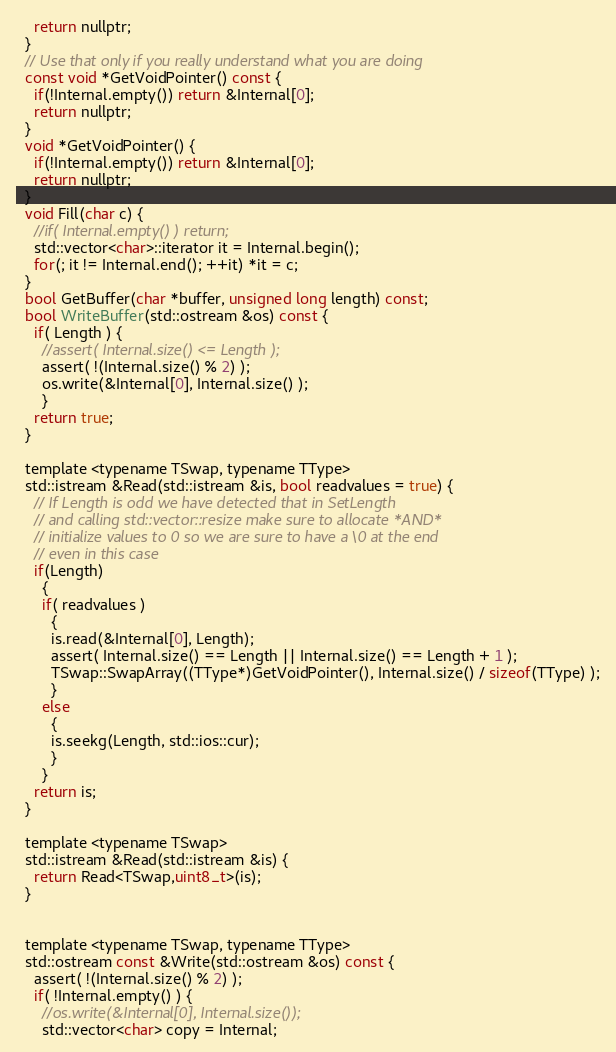<code> <loc_0><loc_0><loc_500><loc_500><_C_>    return nullptr;
  }
  // Use that only if you really understand what you are doing
  const void *GetVoidPointer() const {
    if(!Internal.empty()) return &Internal[0];
    return nullptr;
  }
  void *GetVoidPointer() {
    if(!Internal.empty()) return &Internal[0];
    return nullptr;
  }
  void Fill(char c) {
    //if( Internal.empty() ) return;
    std::vector<char>::iterator it = Internal.begin();
    for(; it != Internal.end(); ++it) *it = c;
  }
  bool GetBuffer(char *buffer, unsigned long length) const;
  bool WriteBuffer(std::ostream &os) const {
    if( Length ) {
      //assert( Internal.size() <= Length );
      assert( !(Internal.size() % 2) );
      os.write(&Internal[0], Internal.size() );
      }
    return true;
  }

  template <typename TSwap, typename TType>
  std::istream &Read(std::istream &is, bool readvalues = true) {
    // If Length is odd we have detected that in SetLength
    // and calling std::vector::resize make sure to allocate *AND*
    // initialize values to 0 so we are sure to have a \0 at the end
    // even in this case
    if(Length)
      {
      if( readvalues )
        {
        is.read(&Internal[0], Length);
        assert( Internal.size() == Length || Internal.size() == Length + 1 );
        TSwap::SwapArray((TType*)GetVoidPointer(), Internal.size() / sizeof(TType) );
        }
      else
        {
        is.seekg(Length, std::ios::cur);
        }
      }
    return is;
  }

  template <typename TSwap>
  std::istream &Read(std::istream &is) {
    return Read<TSwap,uint8_t>(is);
  }


  template <typename TSwap, typename TType>
  std::ostream const &Write(std::ostream &os) const {
    assert( !(Internal.size() % 2) );
    if( !Internal.empty() ) {
      //os.write(&Internal[0], Internal.size());
      std::vector<char> copy = Internal;</code> 